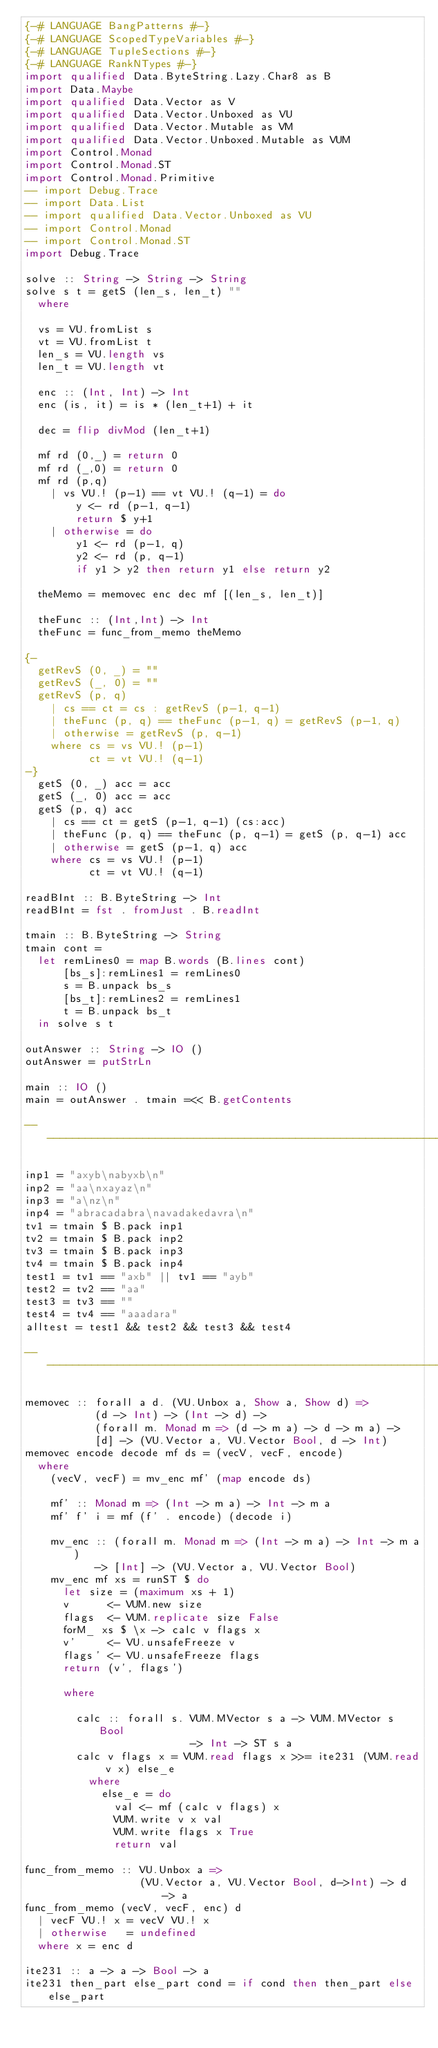Convert code to text. <code><loc_0><loc_0><loc_500><loc_500><_Haskell_>{-# LANGUAGE BangPatterns #-}
{-# LANGUAGE ScopedTypeVariables #-}
{-# LANGUAGE TupleSections #-}
{-# LANGUAGE RankNTypes #-}
import qualified Data.ByteString.Lazy.Char8 as B
import Data.Maybe
import qualified Data.Vector as V
import qualified Data.Vector.Unboxed as VU
import qualified Data.Vector.Mutable as VM
import qualified Data.Vector.Unboxed.Mutable as VUM
import Control.Monad
import Control.Monad.ST
import Control.Monad.Primitive
-- import Debug.Trace
-- import Data.List
-- import qualified Data.Vector.Unboxed as VU
-- import Control.Monad
-- import Control.Monad.ST
import Debug.Trace

solve :: String -> String -> String
solve s t = getS (len_s, len_t) ""
  where

  vs = VU.fromList s
  vt = VU.fromList t
  len_s = VU.length vs
  len_t = VU.length vt

  enc :: (Int, Int) -> Int
  enc (is, it) = is * (len_t+1) + it

  dec = flip divMod (len_t+1)

  mf rd (0,_) = return 0
  mf rd (_,0) = return 0
  mf rd (p,q)
    | vs VU.! (p-1) == vt VU.! (q-1) = do
        y <- rd (p-1, q-1)
        return $ y+1
    | otherwise = do
        y1 <- rd (p-1, q)
        y2 <- rd (p, q-1)
        if y1 > y2 then return y1 else return y2

  theMemo = memovec enc dec mf [(len_s, len_t)]

  theFunc :: (Int,Int) -> Int
  theFunc = func_from_memo theMemo

{-
  getRevS (0, _) = ""
  getRevS (_, 0) = ""
  getRevS (p, q)
    | cs == ct = cs : getRevS (p-1, q-1)
    | theFunc (p, q) == theFunc (p-1, q) = getRevS (p-1, q)
    | otherwise = getRevS (p, q-1)
    where cs = vs VU.! (p-1)
          ct = vt VU.! (q-1)
-}
  getS (0, _) acc = acc
  getS (_, 0) acc = acc
  getS (p, q) acc
    | cs == ct = getS (p-1, q-1) (cs:acc)
    | theFunc (p, q) == theFunc (p, q-1) = getS (p, q-1) acc
    | otherwise = getS (p-1, q) acc
    where cs = vs VU.! (p-1)
          ct = vt VU.! (q-1)

readBInt :: B.ByteString -> Int
readBInt = fst . fromJust . B.readInt

tmain :: B.ByteString -> String
tmain cont =
  let remLines0 = map B.words (B.lines cont)
      [bs_s]:remLines1 = remLines0
      s = B.unpack bs_s
      [bs_t]:remLines2 = remLines1
      t = B.unpack bs_t
  in solve s t

outAnswer :: String -> IO ()
outAnswer = putStrLn

main :: IO ()
main = outAnswer . tmain =<< B.getContents

-------------------------------------------------------------------------------

inp1 = "axyb\nabyxb\n"
inp2 = "aa\nxayaz\n"
inp3 = "a\nz\n"
inp4 = "abracadabra\navadakedavra\n"
tv1 = tmain $ B.pack inp1
tv2 = tmain $ B.pack inp2
tv3 = tmain $ B.pack inp3
tv4 = tmain $ B.pack inp4
test1 = tv1 == "axb" || tv1 == "ayb"
test2 = tv2 == "aa"
test3 = tv3 == ""
test4 = tv4 == "aaadara"
alltest = test1 && test2 && test3 && test4

----------------------------------------------------------------------

memovec :: forall a d. (VU.Unbox a, Show a, Show d) =>
           (d -> Int) -> (Int -> d) ->
           (forall m. Monad m => (d -> m a) -> d -> m a) ->
           [d] -> (VU.Vector a, VU.Vector Bool, d -> Int)
memovec encode decode mf ds = (vecV, vecF, encode)
  where
    (vecV, vecF) = mv_enc mf' (map encode ds)

    mf' :: Monad m => (Int -> m a) -> Int -> m a
    mf' f' i = mf (f' . encode) (decode i)

    mv_enc :: (forall m. Monad m => (Int -> m a) -> Int -> m a)
           -> [Int] -> (VU.Vector a, VU.Vector Bool)
    mv_enc mf xs = runST $ do
      let size = (maximum xs + 1)
      v      <- VUM.new size
      flags  <- VUM.replicate size False
      forM_ xs $ \x -> calc v flags x
      v'     <- VU.unsafeFreeze v
      flags' <- VU.unsafeFreeze flags
      return (v', flags')

      where

        calc :: forall s. VUM.MVector s a -> VUM.MVector s Bool
                          -> Int -> ST s a
        calc v flags x = VUM.read flags x >>= ite231 (VUM.read v x) else_e
          where
            else_e = do
              val <- mf (calc v flags) x
              VUM.write v x val
              VUM.write flags x True
              return val

func_from_memo :: VU.Unbox a =>
                  (VU.Vector a, VU.Vector Bool, d->Int) -> d -> a
func_from_memo (vecV, vecF, enc) d
  | vecF VU.! x = vecV VU.! x
  | otherwise   = undefined
  where x = enc d

ite231 :: a -> a -> Bool -> a
ite231 then_part else_part cond = if cond then then_part else else_part
</code> 